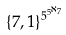<formula> <loc_0><loc_0><loc_500><loc_500>\{ 7 , 1 \} ^ { 5 ^ { 5 ^ { \aleph _ { 7 } } } }</formula> 